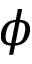<formula> <loc_0><loc_0><loc_500><loc_500>\phi</formula> 